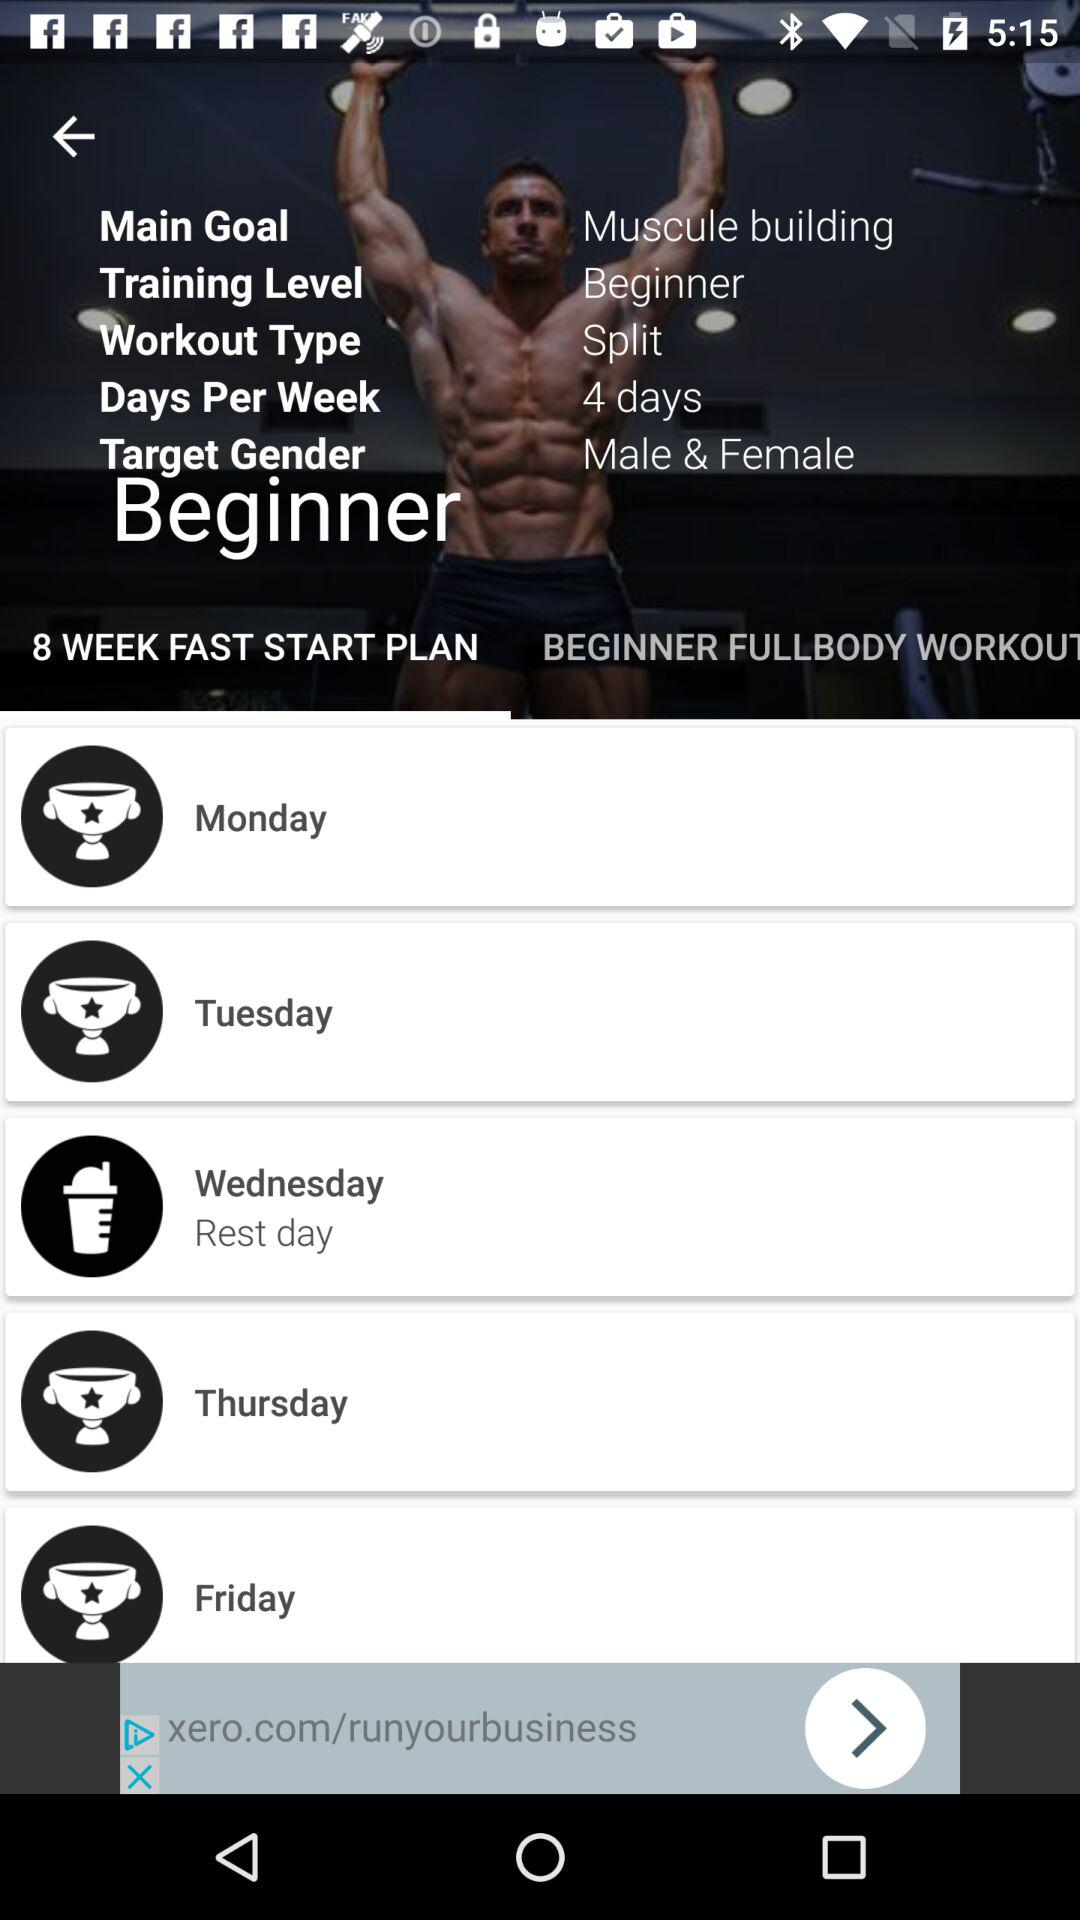What is the target gender? The target genders are male and female. 